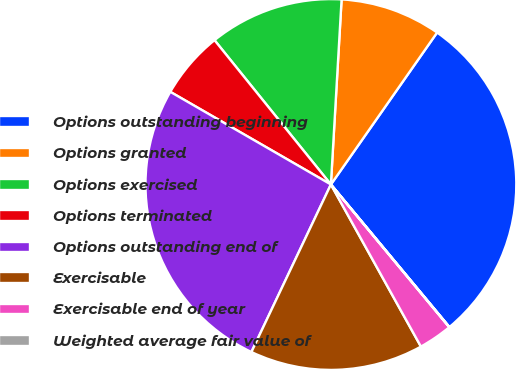<chart> <loc_0><loc_0><loc_500><loc_500><pie_chart><fcel>Options outstanding beginning<fcel>Options granted<fcel>Options exercised<fcel>Options terminated<fcel>Options outstanding end of<fcel>Exercisable<fcel>Exercisable end of year<fcel>Weighted average fair value of<nl><fcel>29.25%<fcel>8.79%<fcel>11.72%<fcel>5.87%<fcel>26.28%<fcel>15.12%<fcel>2.95%<fcel>0.02%<nl></chart> 